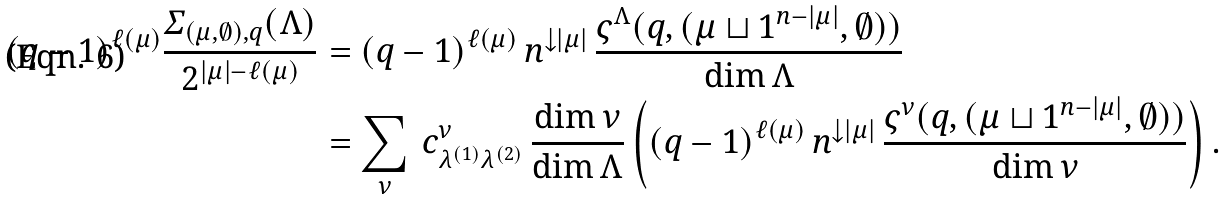Convert formula to latex. <formula><loc_0><loc_0><loc_500><loc_500>( q - 1 ) ^ { \ell ( \mu ) } \frac { \varSigma _ { ( \mu , \emptyset ) , q } ( \Lambda ) } { 2 ^ { | \mu | - \ell ( \mu ) } } & = ( q - 1 ) ^ { \ell ( \mu ) } \, n ^ { \downarrow | \mu | } \, \frac { \varsigma ^ { \Lambda } ( q , ( \mu \sqcup 1 ^ { n - | \mu | } , \emptyset ) ) } { \dim \Lambda } \\ & = \sum _ { \nu } \, c _ { \lambda ^ { ( 1 ) } \lambda ^ { ( 2 ) } } ^ { \nu } \, \frac { \dim \nu } { \dim \Lambda } \left ( ( q - 1 ) ^ { \ell ( \mu ) } \, n ^ { \downarrow | \mu | } \, \frac { \varsigma ^ { \nu } ( q , ( \mu \sqcup 1 ^ { n - | \mu | } , \emptyset ) ) } { \dim \nu } \right ) .</formula> 